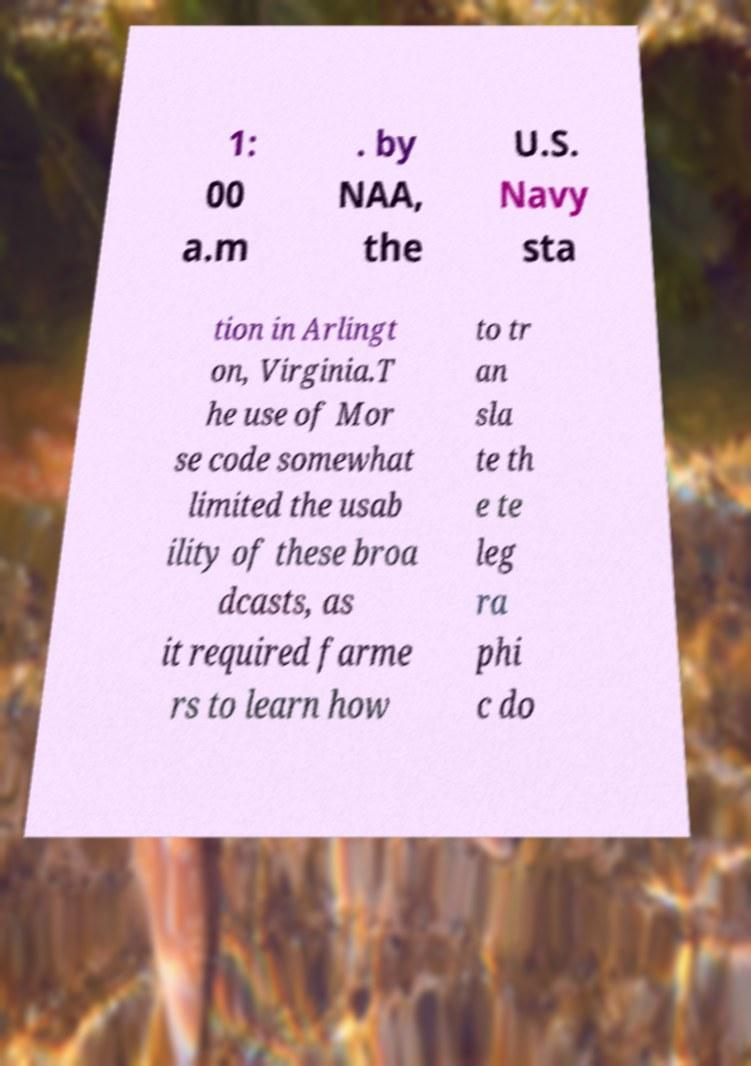Please identify and transcribe the text found in this image. 1: 00 a.m . by NAA, the U.S. Navy sta tion in Arlingt on, Virginia.T he use of Mor se code somewhat limited the usab ility of these broa dcasts, as it required farme rs to learn how to tr an sla te th e te leg ra phi c do 